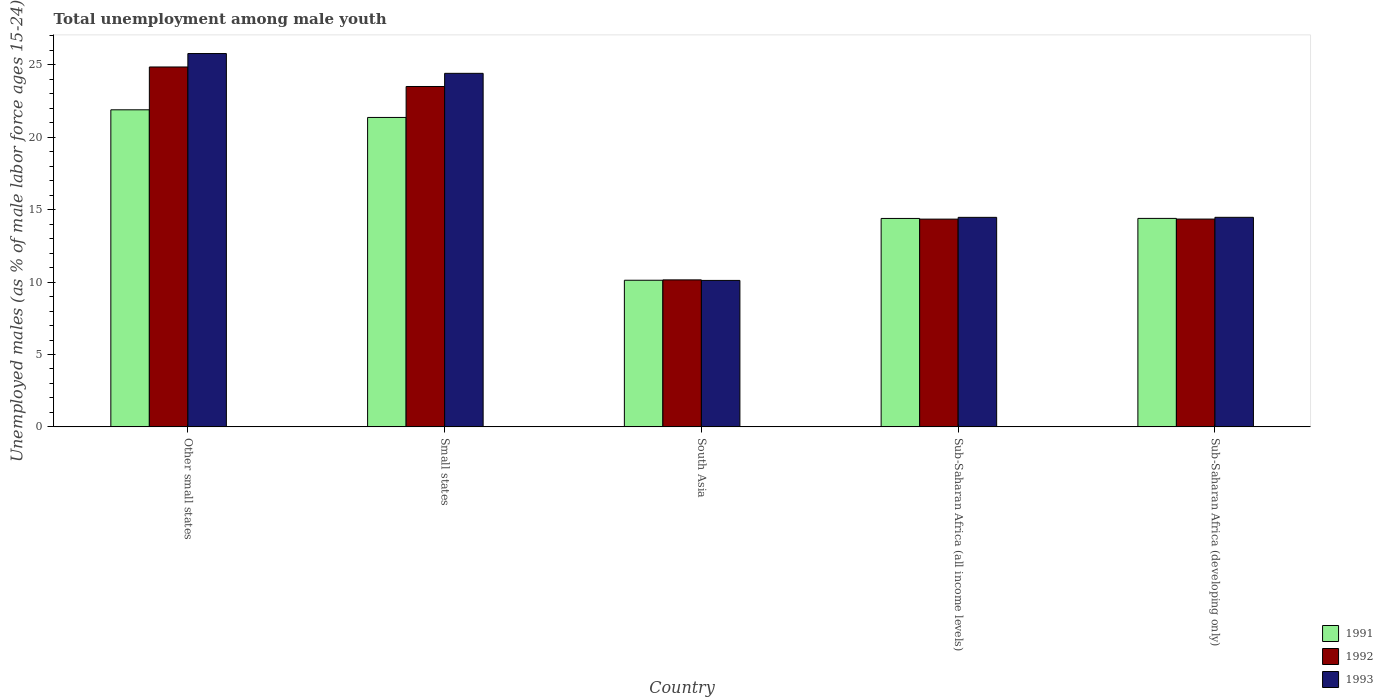How many different coloured bars are there?
Give a very brief answer. 3. Are the number of bars on each tick of the X-axis equal?
Provide a succinct answer. Yes. How many bars are there on the 1st tick from the right?
Your answer should be compact. 3. What is the label of the 5th group of bars from the left?
Your response must be concise. Sub-Saharan Africa (developing only). In how many cases, is the number of bars for a given country not equal to the number of legend labels?
Offer a very short reply. 0. What is the percentage of unemployed males in in 1993 in Small states?
Give a very brief answer. 24.42. Across all countries, what is the maximum percentage of unemployed males in in 1993?
Provide a short and direct response. 25.79. Across all countries, what is the minimum percentage of unemployed males in in 1993?
Offer a terse response. 10.12. In which country was the percentage of unemployed males in in 1991 maximum?
Your answer should be very brief. Other small states. What is the total percentage of unemployed males in in 1991 in the graph?
Offer a terse response. 82.19. What is the difference between the percentage of unemployed males in in 1991 in Small states and that in Sub-Saharan Africa (developing only)?
Provide a succinct answer. 6.97. What is the difference between the percentage of unemployed males in in 1991 in Small states and the percentage of unemployed males in in 1992 in South Asia?
Your answer should be compact. 11.22. What is the average percentage of unemployed males in in 1992 per country?
Make the answer very short. 17.44. What is the difference between the percentage of unemployed males in of/in 1991 and percentage of unemployed males in of/in 1992 in Other small states?
Provide a short and direct response. -2.96. What is the ratio of the percentage of unemployed males in in 1992 in South Asia to that in Sub-Saharan Africa (all income levels)?
Provide a short and direct response. 0.71. Is the percentage of unemployed males in in 1993 in Small states less than that in Sub-Saharan Africa (all income levels)?
Your response must be concise. No. Is the difference between the percentage of unemployed males in in 1991 in Small states and South Asia greater than the difference between the percentage of unemployed males in in 1992 in Small states and South Asia?
Your answer should be very brief. No. What is the difference between the highest and the second highest percentage of unemployed males in in 1991?
Your answer should be compact. -0.53. What is the difference between the highest and the lowest percentage of unemployed males in in 1993?
Ensure brevity in your answer.  15.67. Is the sum of the percentage of unemployed males in in 1993 in South Asia and Sub-Saharan Africa (developing only) greater than the maximum percentage of unemployed males in in 1992 across all countries?
Make the answer very short. No. What does the 3rd bar from the right in Small states represents?
Your response must be concise. 1991. Is it the case that in every country, the sum of the percentage of unemployed males in in 1991 and percentage of unemployed males in in 1993 is greater than the percentage of unemployed males in in 1992?
Your answer should be compact. Yes. How many bars are there?
Your response must be concise. 15. How many countries are there in the graph?
Keep it short and to the point. 5. What is the difference between two consecutive major ticks on the Y-axis?
Give a very brief answer. 5. Does the graph contain any zero values?
Your answer should be compact. No. Does the graph contain grids?
Provide a succinct answer. No. How many legend labels are there?
Your answer should be very brief. 3. How are the legend labels stacked?
Your answer should be very brief. Vertical. What is the title of the graph?
Your answer should be compact. Total unemployment among male youth. What is the label or title of the X-axis?
Offer a very short reply. Country. What is the label or title of the Y-axis?
Your answer should be very brief. Unemployed males (as % of male labor force ages 15-24). What is the Unemployed males (as % of male labor force ages 15-24) of 1991 in Other small states?
Your answer should be very brief. 21.9. What is the Unemployed males (as % of male labor force ages 15-24) in 1992 in Other small states?
Your response must be concise. 24.86. What is the Unemployed males (as % of male labor force ages 15-24) of 1993 in Other small states?
Your answer should be compact. 25.79. What is the Unemployed males (as % of male labor force ages 15-24) in 1991 in Small states?
Provide a short and direct response. 21.37. What is the Unemployed males (as % of male labor force ages 15-24) in 1992 in Small states?
Offer a very short reply. 23.51. What is the Unemployed males (as % of male labor force ages 15-24) of 1993 in Small states?
Provide a short and direct response. 24.42. What is the Unemployed males (as % of male labor force ages 15-24) of 1991 in South Asia?
Provide a succinct answer. 10.13. What is the Unemployed males (as % of male labor force ages 15-24) of 1992 in South Asia?
Your answer should be compact. 10.15. What is the Unemployed males (as % of male labor force ages 15-24) in 1993 in South Asia?
Offer a terse response. 10.12. What is the Unemployed males (as % of male labor force ages 15-24) in 1991 in Sub-Saharan Africa (all income levels)?
Offer a very short reply. 14.4. What is the Unemployed males (as % of male labor force ages 15-24) in 1992 in Sub-Saharan Africa (all income levels)?
Ensure brevity in your answer.  14.35. What is the Unemployed males (as % of male labor force ages 15-24) of 1993 in Sub-Saharan Africa (all income levels)?
Your response must be concise. 14.47. What is the Unemployed males (as % of male labor force ages 15-24) of 1991 in Sub-Saharan Africa (developing only)?
Offer a very short reply. 14.4. What is the Unemployed males (as % of male labor force ages 15-24) in 1992 in Sub-Saharan Africa (developing only)?
Offer a terse response. 14.35. What is the Unemployed males (as % of male labor force ages 15-24) in 1993 in Sub-Saharan Africa (developing only)?
Your answer should be very brief. 14.47. Across all countries, what is the maximum Unemployed males (as % of male labor force ages 15-24) of 1991?
Provide a short and direct response. 21.9. Across all countries, what is the maximum Unemployed males (as % of male labor force ages 15-24) in 1992?
Ensure brevity in your answer.  24.86. Across all countries, what is the maximum Unemployed males (as % of male labor force ages 15-24) in 1993?
Your answer should be very brief. 25.79. Across all countries, what is the minimum Unemployed males (as % of male labor force ages 15-24) of 1991?
Make the answer very short. 10.13. Across all countries, what is the minimum Unemployed males (as % of male labor force ages 15-24) in 1992?
Provide a short and direct response. 10.15. Across all countries, what is the minimum Unemployed males (as % of male labor force ages 15-24) in 1993?
Give a very brief answer. 10.12. What is the total Unemployed males (as % of male labor force ages 15-24) in 1991 in the graph?
Keep it short and to the point. 82.19. What is the total Unemployed males (as % of male labor force ages 15-24) of 1992 in the graph?
Your answer should be very brief. 87.22. What is the total Unemployed males (as % of male labor force ages 15-24) of 1993 in the graph?
Offer a terse response. 89.26. What is the difference between the Unemployed males (as % of male labor force ages 15-24) in 1991 in Other small states and that in Small states?
Provide a succinct answer. 0.53. What is the difference between the Unemployed males (as % of male labor force ages 15-24) of 1992 in Other small states and that in Small states?
Ensure brevity in your answer.  1.35. What is the difference between the Unemployed males (as % of male labor force ages 15-24) of 1993 in Other small states and that in Small states?
Give a very brief answer. 1.37. What is the difference between the Unemployed males (as % of male labor force ages 15-24) in 1991 in Other small states and that in South Asia?
Provide a succinct answer. 11.77. What is the difference between the Unemployed males (as % of male labor force ages 15-24) in 1992 in Other small states and that in South Asia?
Give a very brief answer. 14.7. What is the difference between the Unemployed males (as % of male labor force ages 15-24) in 1993 in Other small states and that in South Asia?
Offer a terse response. 15.67. What is the difference between the Unemployed males (as % of male labor force ages 15-24) in 1991 in Other small states and that in Sub-Saharan Africa (all income levels)?
Provide a short and direct response. 7.5. What is the difference between the Unemployed males (as % of male labor force ages 15-24) of 1992 in Other small states and that in Sub-Saharan Africa (all income levels)?
Provide a succinct answer. 10.51. What is the difference between the Unemployed males (as % of male labor force ages 15-24) in 1993 in Other small states and that in Sub-Saharan Africa (all income levels)?
Your answer should be very brief. 11.31. What is the difference between the Unemployed males (as % of male labor force ages 15-24) in 1991 in Other small states and that in Sub-Saharan Africa (developing only)?
Your answer should be very brief. 7.5. What is the difference between the Unemployed males (as % of male labor force ages 15-24) of 1992 in Other small states and that in Sub-Saharan Africa (developing only)?
Keep it short and to the point. 10.5. What is the difference between the Unemployed males (as % of male labor force ages 15-24) of 1993 in Other small states and that in Sub-Saharan Africa (developing only)?
Provide a short and direct response. 11.31. What is the difference between the Unemployed males (as % of male labor force ages 15-24) in 1991 in Small states and that in South Asia?
Offer a very short reply. 11.24. What is the difference between the Unemployed males (as % of male labor force ages 15-24) in 1992 in Small states and that in South Asia?
Offer a terse response. 13.36. What is the difference between the Unemployed males (as % of male labor force ages 15-24) in 1993 in Small states and that in South Asia?
Your answer should be compact. 14.3. What is the difference between the Unemployed males (as % of male labor force ages 15-24) of 1991 in Small states and that in Sub-Saharan Africa (all income levels)?
Ensure brevity in your answer.  6.98. What is the difference between the Unemployed males (as % of male labor force ages 15-24) of 1992 in Small states and that in Sub-Saharan Africa (all income levels)?
Keep it short and to the point. 9.16. What is the difference between the Unemployed males (as % of male labor force ages 15-24) in 1993 in Small states and that in Sub-Saharan Africa (all income levels)?
Offer a very short reply. 9.95. What is the difference between the Unemployed males (as % of male labor force ages 15-24) of 1991 in Small states and that in Sub-Saharan Africa (developing only)?
Offer a terse response. 6.97. What is the difference between the Unemployed males (as % of male labor force ages 15-24) of 1992 in Small states and that in Sub-Saharan Africa (developing only)?
Keep it short and to the point. 9.16. What is the difference between the Unemployed males (as % of male labor force ages 15-24) of 1993 in Small states and that in Sub-Saharan Africa (developing only)?
Make the answer very short. 9.94. What is the difference between the Unemployed males (as % of male labor force ages 15-24) in 1991 in South Asia and that in Sub-Saharan Africa (all income levels)?
Offer a terse response. -4.27. What is the difference between the Unemployed males (as % of male labor force ages 15-24) in 1992 in South Asia and that in Sub-Saharan Africa (all income levels)?
Make the answer very short. -4.2. What is the difference between the Unemployed males (as % of male labor force ages 15-24) in 1993 in South Asia and that in Sub-Saharan Africa (all income levels)?
Provide a succinct answer. -4.36. What is the difference between the Unemployed males (as % of male labor force ages 15-24) of 1991 in South Asia and that in Sub-Saharan Africa (developing only)?
Provide a succinct answer. -4.27. What is the difference between the Unemployed males (as % of male labor force ages 15-24) in 1992 in South Asia and that in Sub-Saharan Africa (developing only)?
Keep it short and to the point. -4.2. What is the difference between the Unemployed males (as % of male labor force ages 15-24) of 1993 in South Asia and that in Sub-Saharan Africa (developing only)?
Offer a very short reply. -4.36. What is the difference between the Unemployed males (as % of male labor force ages 15-24) in 1991 in Sub-Saharan Africa (all income levels) and that in Sub-Saharan Africa (developing only)?
Make the answer very short. -0. What is the difference between the Unemployed males (as % of male labor force ages 15-24) in 1992 in Sub-Saharan Africa (all income levels) and that in Sub-Saharan Africa (developing only)?
Your answer should be compact. -0. What is the difference between the Unemployed males (as % of male labor force ages 15-24) in 1993 in Sub-Saharan Africa (all income levels) and that in Sub-Saharan Africa (developing only)?
Your response must be concise. -0. What is the difference between the Unemployed males (as % of male labor force ages 15-24) of 1991 in Other small states and the Unemployed males (as % of male labor force ages 15-24) of 1992 in Small states?
Keep it short and to the point. -1.61. What is the difference between the Unemployed males (as % of male labor force ages 15-24) of 1991 in Other small states and the Unemployed males (as % of male labor force ages 15-24) of 1993 in Small states?
Keep it short and to the point. -2.52. What is the difference between the Unemployed males (as % of male labor force ages 15-24) in 1992 in Other small states and the Unemployed males (as % of male labor force ages 15-24) in 1993 in Small states?
Keep it short and to the point. 0.44. What is the difference between the Unemployed males (as % of male labor force ages 15-24) in 1991 in Other small states and the Unemployed males (as % of male labor force ages 15-24) in 1992 in South Asia?
Give a very brief answer. 11.75. What is the difference between the Unemployed males (as % of male labor force ages 15-24) of 1991 in Other small states and the Unemployed males (as % of male labor force ages 15-24) of 1993 in South Asia?
Ensure brevity in your answer.  11.78. What is the difference between the Unemployed males (as % of male labor force ages 15-24) in 1992 in Other small states and the Unemployed males (as % of male labor force ages 15-24) in 1993 in South Asia?
Offer a terse response. 14.74. What is the difference between the Unemployed males (as % of male labor force ages 15-24) in 1991 in Other small states and the Unemployed males (as % of male labor force ages 15-24) in 1992 in Sub-Saharan Africa (all income levels)?
Ensure brevity in your answer.  7.55. What is the difference between the Unemployed males (as % of male labor force ages 15-24) in 1991 in Other small states and the Unemployed males (as % of male labor force ages 15-24) in 1993 in Sub-Saharan Africa (all income levels)?
Make the answer very short. 7.43. What is the difference between the Unemployed males (as % of male labor force ages 15-24) in 1992 in Other small states and the Unemployed males (as % of male labor force ages 15-24) in 1993 in Sub-Saharan Africa (all income levels)?
Offer a terse response. 10.39. What is the difference between the Unemployed males (as % of male labor force ages 15-24) of 1991 in Other small states and the Unemployed males (as % of male labor force ages 15-24) of 1992 in Sub-Saharan Africa (developing only)?
Make the answer very short. 7.55. What is the difference between the Unemployed males (as % of male labor force ages 15-24) of 1991 in Other small states and the Unemployed males (as % of male labor force ages 15-24) of 1993 in Sub-Saharan Africa (developing only)?
Your answer should be compact. 7.43. What is the difference between the Unemployed males (as % of male labor force ages 15-24) in 1992 in Other small states and the Unemployed males (as % of male labor force ages 15-24) in 1993 in Sub-Saharan Africa (developing only)?
Your answer should be compact. 10.38. What is the difference between the Unemployed males (as % of male labor force ages 15-24) in 1991 in Small states and the Unemployed males (as % of male labor force ages 15-24) in 1992 in South Asia?
Your answer should be compact. 11.22. What is the difference between the Unemployed males (as % of male labor force ages 15-24) of 1991 in Small states and the Unemployed males (as % of male labor force ages 15-24) of 1993 in South Asia?
Your answer should be very brief. 11.26. What is the difference between the Unemployed males (as % of male labor force ages 15-24) of 1992 in Small states and the Unemployed males (as % of male labor force ages 15-24) of 1993 in South Asia?
Your answer should be compact. 13.39. What is the difference between the Unemployed males (as % of male labor force ages 15-24) of 1991 in Small states and the Unemployed males (as % of male labor force ages 15-24) of 1992 in Sub-Saharan Africa (all income levels)?
Offer a terse response. 7.02. What is the difference between the Unemployed males (as % of male labor force ages 15-24) of 1991 in Small states and the Unemployed males (as % of male labor force ages 15-24) of 1993 in Sub-Saharan Africa (all income levels)?
Your answer should be compact. 6.9. What is the difference between the Unemployed males (as % of male labor force ages 15-24) in 1992 in Small states and the Unemployed males (as % of male labor force ages 15-24) in 1993 in Sub-Saharan Africa (all income levels)?
Provide a succinct answer. 9.04. What is the difference between the Unemployed males (as % of male labor force ages 15-24) in 1991 in Small states and the Unemployed males (as % of male labor force ages 15-24) in 1992 in Sub-Saharan Africa (developing only)?
Keep it short and to the point. 7.02. What is the difference between the Unemployed males (as % of male labor force ages 15-24) of 1991 in Small states and the Unemployed males (as % of male labor force ages 15-24) of 1993 in Sub-Saharan Africa (developing only)?
Provide a succinct answer. 6.9. What is the difference between the Unemployed males (as % of male labor force ages 15-24) of 1992 in Small states and the Unemployed males (as % of male labor force ages 15-24) of 1993 in Sub-Saharan Africa (developing only)?
Your response must be concise. 9.04. What is the difference between the Unemployed males (as % of male labor force ages 15-24) in 1991 in South Asia and the Unemployed males (as % of male labor force ages 15-24) in 1992 in Sub-Saharan Africa (all income levels)?
Offer a very short reply. -4.22. What is the difference between the Unemployed males (as % of male labor force ages 15-24) of 1991 in South Asia and the Unemployed males (as % of male labor force ages 15-24) of 1993 in Sub-Saharan Africa (all income levels)?
Your answer should be very brief. -4.34. What is the difference between the Unemployed males (as % of male labor force ages 15-24) of 1992 in South Asia and the Unemployed males (as % of male labor force ages 15-24) of 1993 in Sub-Saharan Africa (all income levels)?
Give a very brief answer. -4.32. What is the difference between the Unemployed males (as % of male labor force ages 15-24) of 1991 in South Asia and the Unemployed males (as % of male labor force ages 15-24) of 1992 in Sub-Saharan Africa (developing only)?
Offer a terse response. -4.22. What is the difference between the Unemployed males (as % of male labor force ages 15-24) of 1991 in South Asia and the Unemployed males (as % of male labor force ages 15-24) of 1993 in Sub-Saharan Africa (developing only)?
Your answer should be very brief. -4.35. What is the difference between the Unemployed males (as % of male labor force ages 15-24) of 1992 in South Asia and the Unemployed males (as % of male labor force ages 15-24) of 1993 in Sub-Saharan Africa (developing only)?
Give a very brief answer. -4.32. What is the difference between the Unemployed males (as % of male labor force ages 15-24) of 1991 in Sub-Saharan Africa (all income levels) and the Unemployed males (as % of male labor force ages 15-24) of 1992 in Sub-Saharan Africa (developing only)?
Make the answer very short. 0.04. What is the difference between the Unemployed males (as % of male labor force ages 15-24) in 1991 in Sub-Saharan Africa (all income levels) and the Unemployed males (as % of male labor force ages 15-24) in 1993 in Sub-Saharan Africa (developing only)?
Provide a succinct answer. -0.08. What is the difference between the Unemployed males (as % of male labor force ages 15-24) of 1992 in Sub-Saharan Africa (all income levels) and the Unemployed males (as % of male labor force ages 15-24) of 1993 in Sub-Saharan Africa (developing only)?
Provide a succinct answer. -0.12. What is the average Unemployed males (as % of male labor force ages 15-24) in 1991 per country?
Your answer should be compact. 16.44. What is the average Unemployed males (as % of male labor force ages 15-24) in 1992 per country?
Keep it short and to the point. 17.44. What is the average Unemployed males (as % of male labor force ages 15-24) of 1993 per country?
Your response must be concise. 17.85. What is the difference between the Unemployed males (as % of male labor force ages 15-24) of 1991 and Unemployed males (as % of male labor force ages 15-24) of 1992 in Other small states?
Make the answer very short. -2.96. What is the difference between the Unemployed males (as % of male labor force ages 15-24) in 1991 and Unemployed males (as % of male labor force ages 15-24) in 1993 in Other small states?
Give a very brief answer. -3.89. What is the difference between the Unemployed males (as % of male labor force ages 15-24) of 1992 and Unemployed males (as % of male labor force ages 15-24) of 1993 in Other small states?
Provide a short and direct response. -0.93. What is the difference between the Unemployed males (as % of male labor force ages 15-24) of 1991 and Unemployed males (as % of male labor force ages 15-24) of 1992 in Small states?
Keep it short and to the point. -2.14. What is the difference between the Unemployed males (as % of male labor force ages 15-24) in 1991 and Unemployed males (as % of male labor force ages 15-24) in 1993 in Small states?
Offer a very short reply. -3.05. What is the difference between the Unemployed males (as % of male labor force ages 15-24) in 1992 and Unemployed males (as % of male labor force ages 15-24) in 1993 in Small states?
Offer a very short reply. -0.91. What is the difference between the Unemployed males (as % of male labor force ages 15-24) of 1991 and Unemployed males (as % of male labor force ages 15-24) of 1992 in South Asia?
Offer a terse response. -0.02. What is the difference between the Unemployed males (as % of male labor force ages 15-24) in 1991 and Unemployed males (as % of male labor force ages 15-24) in 1993 in South Asia?
Make the answer very short. 0.01. What is the difference between the Unemployed males (as % of male labor force ages 15-24) in 1992 and Unemployed males (as % of male labor force ages 15-24) in 1993 in South Asia?
Offer a terse response. 0.04. What is the difference between the Unemployed males (as % of male labor force ages 15-24) in 1991 and Unemployed males (as % of male labor force ages 15-24) in 1992 in Sub-Saharan Africa (all income levels)?
Provide a succinct answer. 0.05. What is the difference between the Unemployed males (as % of male labor force ages 15-24) in 1991 and Unemployed males (as % of male labor force ages 15-24) in 1993 in Sub-Saharan Africa (all income levels)?
Keep it short and to the point. -0.08. What is the difference between the Unemployed males (as % of male labor force ages 15-24) of 1992 and Unemployed males (as % of male labor force ages 15-24) of 1993 in Sub-Saharan Africa (all income levels)?
Keep it short and to the point. -0.12. What is the difference between the Unemployed males (as % of male labor force ages 15-24) of 1991 and Unemployed males (as % of male labor force ages 15-24) of 1992 in Sub-Saharan Africa (developing only)?
Your answer should be compact. 0.05. What is the difference between the Unemployed males (as % of male labor force ages 15-24) in 1991 and Unemployed males (as % of male labor force ages 15-24) in 1993 in Sub-Saharan Africa (developing only)?
Provide a short and direct response. -0.07. What is the difference between the Unemployed males (as % of male labor force ages 15-24) in 1992 and Unemployed males (as % of male labor force ages 15-24) in 1993 in Sub-Saharan Africa (developing only)?
Keep it short and to the point. -0.12. What is the ratio of the Unemployed males (as % of male labor force ages 15-24) in 1991 in Other small states to that in Small states?
Offer a terse response. 1.02. What is the ratio of the Unemployed males (as % of male labor force ages 15-24) of 1992 in Other small states to that in Small states?
Ensure brevity in your answer.  1.06. What is the ratio of the Unemployed males (as % of male labor force ages 15-24) in 1993 in Other small states to that in Small states?
Offer a very short reply. 1.06. What is the ratio of the Unemployed males (as % of male labor force ages 15-24) in 1991 in Other small states to that in South Asia?
Make the answer very short. 2.16. What is the ratio of the Unemployed males (as % of male labor force ages 15-24) in 1992 in Other small states to that in South Asia?
Your answer should be very brief. 2.45. What is the ratio of the Unemployed males (as % of male labor force ages 15-24) of 1993 in Other small states to that in South Asia?
Make the answer very short. 2.55. What is the ratio of the Unemployed males (as % of male labor force ages 15-24) of 1991 in Other small states to that in Sub-Saharan Africa (all income levels)?
Make the answer very short. 1.52. What is the ratio of the Unemployed males (as % of male labor force ages 15-24) of 1992 in Other small states to that in Sub-Saharan Africa (all income levels)?
Provide a succinct answer. 1.73. What is the ratio of the Unemployed males (as % of male labor force ages 15-24) of 1993 in Other small states to that in Sub-Saharan Africa (all income levels)?
Your response must be concise. 1.78. What is the ratio of the Unemployed males (as % of male labor force ages 15-24) of 1991 in Other small states to that in Sub-Saharan Africa (developing only)?
Offer a terse response. 1.52. What is the ratio of the Unemployed males (as % of male labor force ages 15-24) of 1992 in Other small states to that in Sub-Saharan Africa (developing only)?
Make the answer very short. 1.73. What is the ratio of the Unemployed males (as % of male labor force ages 15-24) of 1993 in Other small states to that in Sub-Saharan Africa (developing only)?
Offer a very short reply. 1.78. What is the ratio of the Unemployed males (as % of male labor force ages 15-24) in 1991 in Small states to that in South Asia?
Your answer should be very brief. 2.11. What is the ratio of the Unemployed males (as % of male labor force ages 15-24) of 1992 in Small states to that in South Asia?
Keep it short and to the point. 2.32. What is the ratio of the Unemployed males (as % of male labor force ages 15-24) in 1993 in Small states to that in South Asia?
Your response must be concise. 2.41. What is the ratio of the Unemployed males (as % of male labor force ages 15-24) of 1991 in Small states to that in Sub-Saharan Africa (all income levels)?
Your answer should be compact. 1.48. What is the ratio of the Unemployed males (as % of male labor force ages 15-24) of 1992 in Small states to that in Sub-Saharan Africa (all income levels)?
Your answer should be very brief. 1.64. What is the ratio of the Unemployed males (as % of male labor force ages 15-24) in 1993 in Small states to that in Sub-Saharan Africa (all income levels)?
Your answer should be compact. 1.69. What is the ratio of the Unemployed males (as % of male labor force ages 15-24) in 1991 in Small states to that in Sub-Saharan Africa (developing only)?
Offer a very short reply. 1.48. What is the ratio of the Unemployed males (as % of male labor force ages 15-24) of 1992 in Small states to that in Sub-Saharan Africa (developing only)?
Ensure brevity in your answer.  1.64. What is the ratio of the Unemployed males (as % of male labor force ages 15-24) of 1993 in Small states to that in Sub-Saharan Africa (developing only)?
Your answer should be very brief. 1.69. What is the ratio of the Unemployed males (as % of male labor force ages 15-24) of 1991 in South Asia to that in Sub-Saharan Africa (all income levels)?
Offer a very short reply. 0.7. What is the ratio of the Unemployed males (as % of male labor force ages 15-24) of 1992 in South Asia to that in Sub-Saharan Africa (all income levels)?
Your answer should be very brief. 0.71. What is the ratio of the Unemployed males (as % of male labor force ages 15-24) of 1993 in South Asia to that in Sub-Saharan Africa (all income levels)?
Make the answer very short. 0.7. What is the ratio of the Unemployed males (as % of male labor force ages 15-24) of 1991 in South Asia to that in Sub-Saharan Africa (developing only)?
Provide a short and direct response. 0.7. What is the ratio of the Unemployed males (as % of male labor force ages 15-24) of 1992 in South Asia to that in Sub-Saharan Africa (developing only)?
Ensure brevity in your answer.  0.71. What is the ratio of the Unemployed males (as % of male labor force ages 15-24) in 1993 in South Asia to that in Sub-Saharan Africa (developing only)?
Ensure brevity in your answer.  0.7. What is the ratio of the Unemployed males (as % of male labor force ages 15-24) in 1991 in Sub-Saharan Africa (all income levels) to that in Sub-Saharan Africa (developing only)?
Offer a terse response. 1. What is the ratio of the Unemployed males (as % of male labor force ages 15-24) of 1992 in Sub-Saharan Africa (all income levels) to that in Sub-Saharan Africa (developing only)?
Your answer should be compact. 1. What is the difference between the highest and the second highest Unemployed males (as % of male labor force ages 15-24) in 1991?
Make the answer very short. 0.53. What is the difference between the highest and the second highest Unemployed males (as % of male labor force ages 15-24) of 1992?
Your answer should be very brief. 1.35. What is the difference between the highest and the second highest Unemployed males (as % of male labor force ages 15-24) of 1993?
Offer a terse response. 1.37. What is the difference between the highest and the lowest Unemployed males (as % of male labor force ages 15-24) of 1991?
Your answer should be very brief. 11.77. What is the difference between the highest and the lowest Unemployed males (as % of male labor force ages 15-24) of 1992?
Give a very brief answer. 14.7. What is the difference between the highest and the lowest Unemployed males (as % of male labor force ages 15-24) of 1993?
Your answer should be compact. 15.67. 